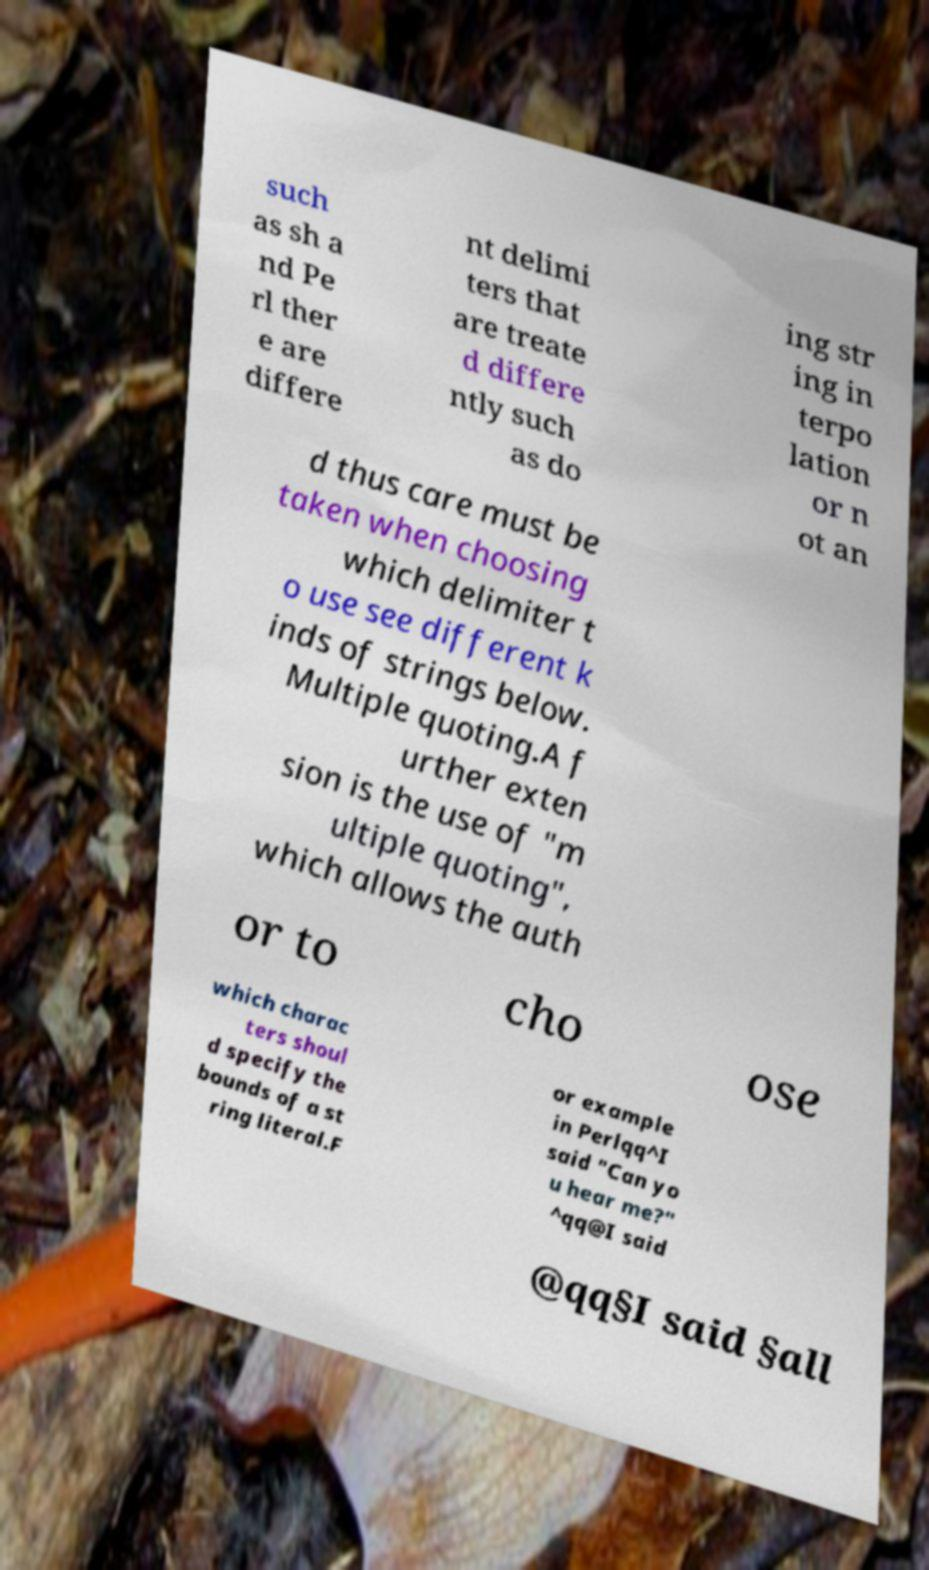Please read and relay the text visible in this image. What does it say? such as sh a nd Pe rl ther e are differe nt delimi ters that are treate d differe ntly such as do ing str ing in terpo lation or n ot an d thus care must be taken when choosing which delimiter t o use see different k inds of strings below. Multiple quoting.A f urther exten sion is the use of "m ultiple quoting", which allows the auth or to cho ose which charac ters shoul d specify the bounds of a st ring literal.F or example in Perlqq^I said "Can yo u hear me?" ^qq@I said @qq§I said §all 